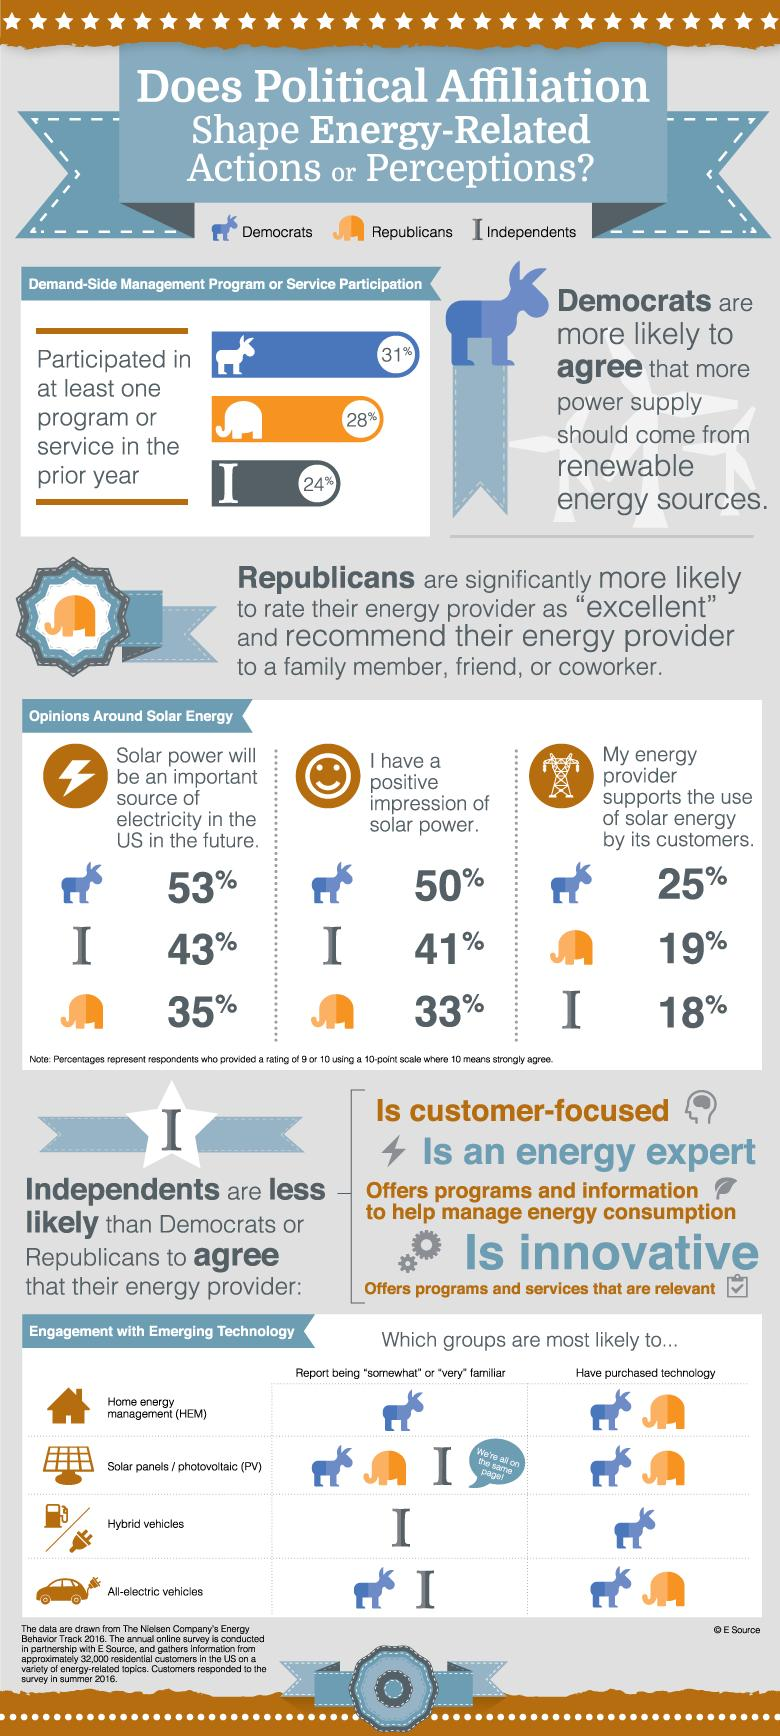Give some essential details in this illustration. In the prior year, 24% of Independents participated in demand side management (DSM) programs or services. According to a recent poll, 50% of Democrats have a positive impression of solar power. According to the data provided, Democrats are more familiar with the concept of home energy management compared to other groups. The results of the survey showed that Democrats and Republicans were the groups that had mostly purchased solar panels and all-electric vehicles. A recent survey has revealed that 35% of Republicans believe that solar power will be the primary source of electricity in the future. 